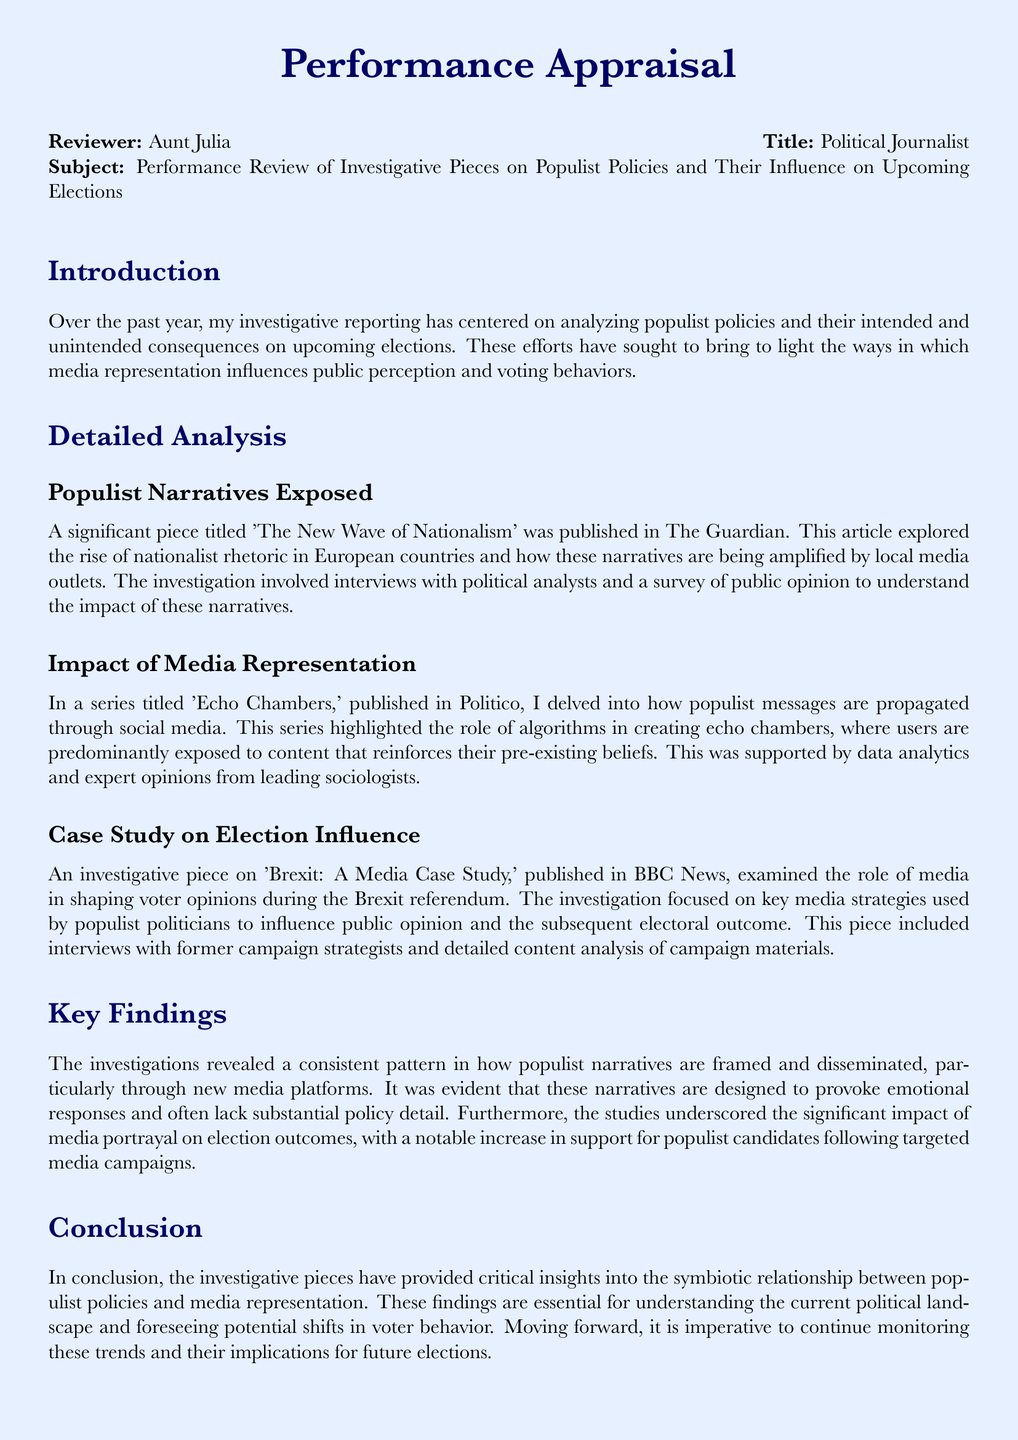What is the main focus of the investigative reporting? The main focus of the investigative reporting is analyzing populist policies and their intended and unintended consequences on upcoming elections.
Answer: populist policies Which publication featured the article titled 'The New Wave of Nationalism'? 'The New Wave of Nationalism' was published in The Guardian.
Answer: The Guardian What was examined in the piece titled 'Brexit: A Media Case Study'? 'Brexit: A Media Case Study' examined the role of media in shaping voter opinions during the Brexit referendum.
Answer: role of media What key themes are explored in the series titled 'Echo Chambers'? The key themes explored in 'Echo Chambers' include how populist messages are propagated through social media and the role of algorithms.
Answer: social media and algorithms How many investigations are briefly described in the document? There are three investigations described in the document.
Answer: three What type of analysis was included in the article on the Brexit referendum? The article included content analysis of campaign materials.
Answer: content analysis What is identified as a significant impact on election outcomes? The significant impact on election outcomes is the media portrayal of populist candidates.
Answer: media portrayal Which group of professionals did the investigation on 'The New Wave of Nationalism' involve interviews with? The investigation involved interviews with political analysts.
Answer: political analysts What conclusion is drawn about populist narratives? The conclusion drawn is that populist narratives are designed to provoke emotional responses and often lack substantial policy detail.
Answer: provoke emotional responses 